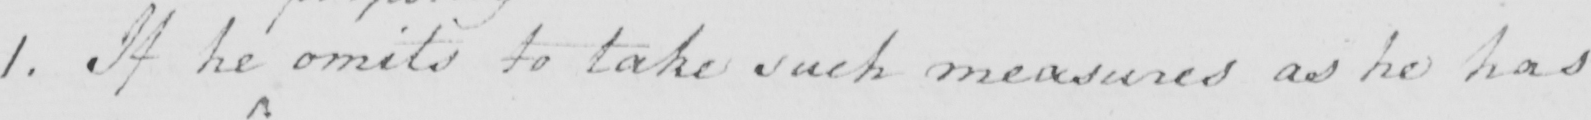What is written in this line of handwriting? 1 . If he omits to take such measures as he has 